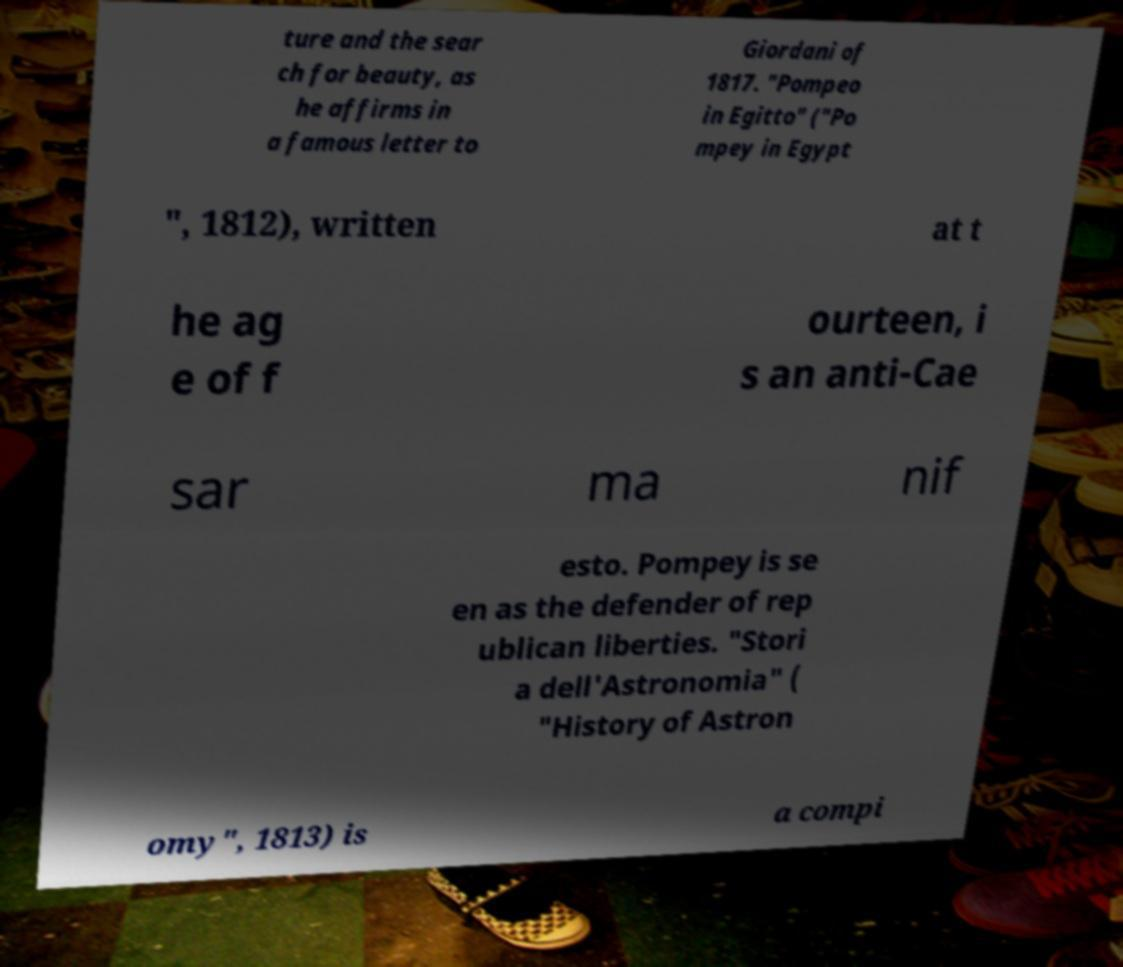For documentation purposes, I need the text within this image transcribed. Could you provide that? ture and the sear ch for beauty, as he affirms in a famous letter to Giordani of 1817. "Pompeo in Egitto" ("Po mpey in Egypt ", 1812), written at t he ag e of f ourteen, i s an anti-Cae sar ma nif esto. Pompey is se en as the defender of rep ublican liberties. "Stori a dell'Astronomia" ( "History of Astron omy", 1813) is a compi 